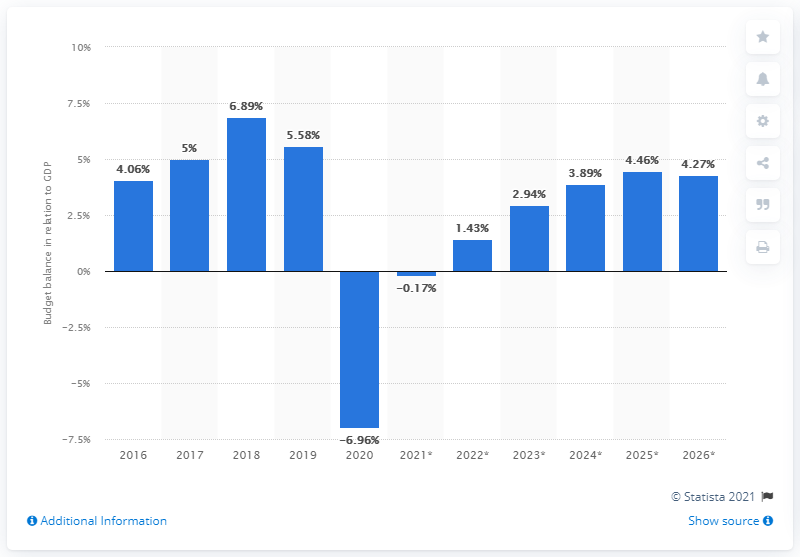Give some essential details in this illustration. Norway's budget balance last year was in relation to its GDP in 2020. 